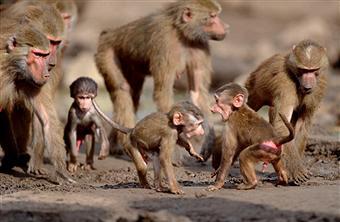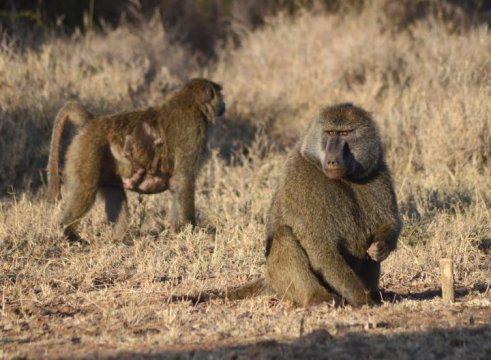The first image is the image on the left, the second image is the image on the right. Evaluate the accuracy of this statement regarding the images: "At least one of the images contains a baby monkey.". Is it true? Answer yes or no. Yes. 